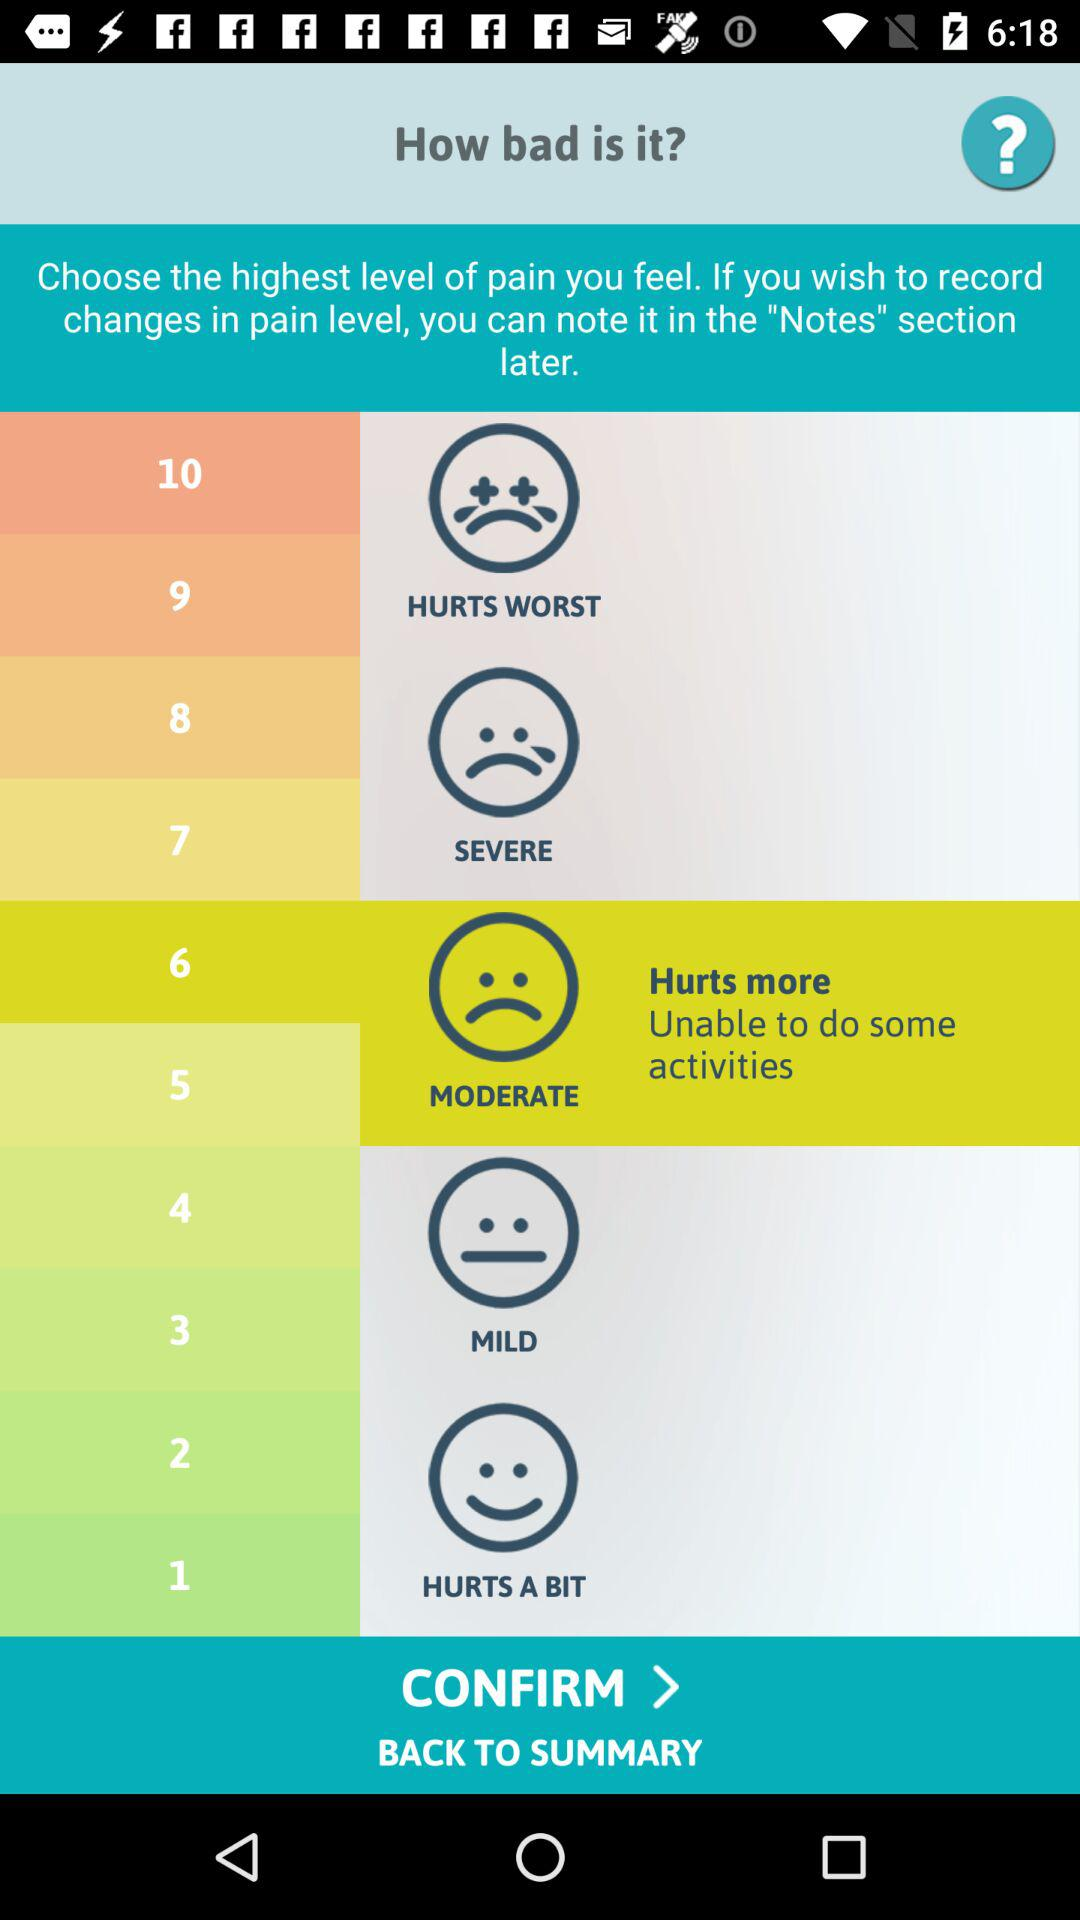What is the feeling for numbers 9 & 10? The feeling for numbers 9 & 10 is "HURTS WORST". 